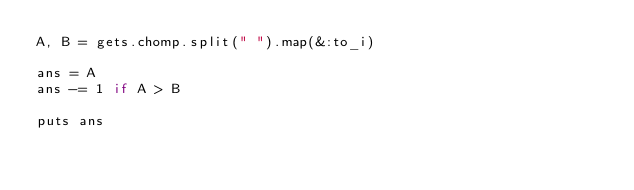<code> <loc_0><loc_0><loc_500><loc_500><_Ruby_>A, B = gets.chomp.split(" ").map(&:to_i)

ans = A
ans -= 1 if A > B

puts ans
</code> 